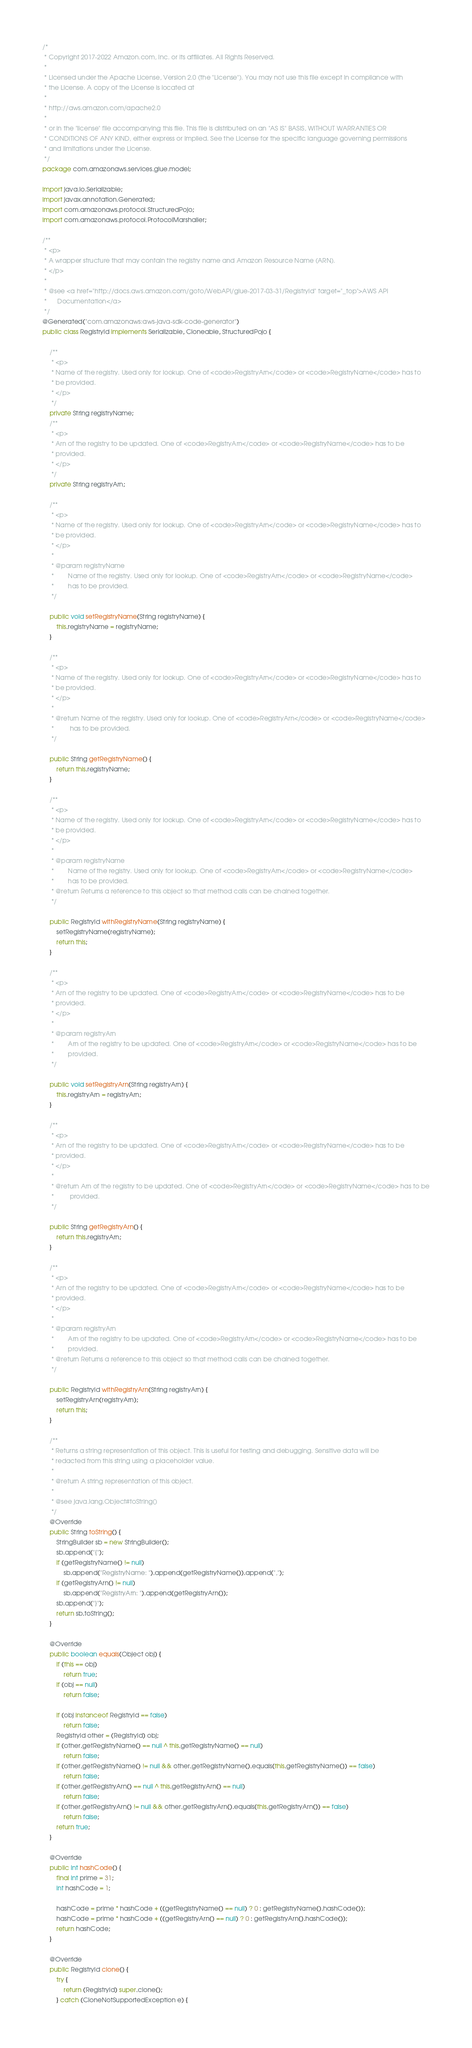<code> <loc_0><loc_0><loc_500><loc_500><_Java_>/*
 * Copyright 2017-2022 Amazon.com, Inc. or its affiliates. All Rights Reserved.
 * 
 * Licensed under the Apache License, Version 2.0 (the "License"). You may not use this file except in compliance with
 * the License. A copy of the License is located at
 * 
 * http://aws.amazon.com/apache2.0
 * 
 * or in the "license" file accompanying this file. This file is distributed on an "AS IS" BASIS, WITHOUT WARRANTIES OR
 * CONDITIONS OF ANY KIND, either express or implied. See the License for the specific language governing permissions
 * and limitations under the License.
 */
package com.amazonaws.services.glue.model;

import java.io.Serializable;
import javax.annotation.Generated;
import com.amazonaws.protocol.StructuredPojo;
import com.amazonaws.protocol.ProtocolMarshaller;

/**
 * <p>
 * A wrapper structure that may contain the registry name and Amazon Resource Name (ARN).
 * </p>
 * 
 * @see <a href="http://docs.aws.amazon.com/goto/WebAPI/glue-2017-03-31/RegistryId" target="_top">AWS API
 *      Documentation</a>
 */
@Generated("com.amazonaws:aws-java-sdk-code-generator")
public class RegistryId implements Serializable, Cloneable, StructuredPojo {

    /**
     * <p>
     * Name of the registry. Used only for lookup. One of <code>RegistryArn</code> or <code>RegistryName</code> has to
     * be provided.
     * </p>
     */
    private String registryName;
    /**
     * <p>
     * Arn of the registry to be updated. One of <code>RegistryArn</code> or <code>RegistryName</code> has to be
     * provided.
     * </p>
     */
    private String registryArn;

    /**
     * <p>
     * Name of the registry. Used only for lookup. One of <code>RegistryArn</code> or <code>RegistryName</code> has to
     * be provided.
     * </p>
     * 
     * @param registryName
     *        Name of the registry. Used only for lookup. One of <code>RegistryArn</code> or <code>RegistryName</code>
     *        has to be provided.
     */

    public void setRegistryName(String registryName) {
        this.registryName = registryName;
    }

    /**
     * <p>
     * Name of the registry. Used only for lookup. One of <code>RegistryArn</code> or <code>RegistryName</code> has to
     * be provided.
     * </p>
     * 
     * @return Name of the registry. Used only for lookup. One of <code>RegistryArn</code> or <code>RegistryName</code>
     *         has to be provided.
     */

    public String getRegistryName() {
        return this.registryName;
    }

    /**
     * <p>
     * Name of the registry. Used only for lookup. One of <code>RegistryArn</code> or <code>RegistryName</code> has to
     * be provided.
     * </p>
     * 
     * @param registryName
     *        Name of the registry. Used only for lookup. One of <code>RegistryArn</code> or <code>RegistryName</code>
     *        has to be provided.
     * @return Returns a reference to this object so that method calls can be chained together.
     */

    public RegistryId withRegistryName(String registryName) {
        setRegistryName(registryName);
        return this;
    }

    /**
     * <p>
     * Arn of the registry to be updated. One of <code>RegistryArn</code> or <code>RegistryName</code> has to be
     * provided.
     * </p>
     * 
     * @param registryArn
     *        Arn of the registry to be updated. One of <code>RegistryArn</code> or <code>RegistryName</code> has to be
     *        provided.
     */

    public void setRegistryArn(String registryArn) {
        this.registryArn = registryArn;
    }

    /**
     * <p>
     * Arn of the registry to be updated. One of <code>RegistryArn</code> or <code>RegistryName</code> has to be
     * provided.
     * </p>
     * 
     * @return Arn of the registry to be updated. One of <code>RegistryArn</code> or <code>RegistryName</code> has to be
     *         provided.
     */

    public String getRegistryArn() {
        return this.registryArn;
    }

    /**
     * <p>
     * Arn of the registry to be updated. One of <code>RegistryArn</code> or <code>RegistryName</code> has to be
     * provided.
     * </p>
     * 
     * @param registryArn
     *        Arn of the registry to be updated. One of <code>RegistryArn</code> or <code>RegistryName</code> has to be
     *        provided.
     * @return Returns a reference to this object so that method calls can be chained together.
     */

    public RegistryId withRegistryArn(String registryArn) {
        setRegistryArn(registryArn);
        return this;
    }

    /**
     * Returns a string representation of this object. This is useful for testing and debugging. Sensitive data will be
     * redacted from this string using a placeholder value.
     *
     * @return A string representation of this object.
     *
     * @see java.lang.Object#toString()
     */
    @Override
    public String toString() {
        StringBuilder sb = new StringBuilder();
        sb.append("{");
        if (getRegistryName() != null)
            sb.append("RegistryName: ").append(getRegistryName()).append(",");
        if (getRegistryArn() != null)
            sb.append("RegistryArn: ").append(getRegistryArn());
        sb.append("}");
        return sb.toString();
    }

    @Override
    public boolean equals(Object obj) {
        if (this == obj)
            return true;
        if (obj == null)
            return false;

        if (obj instanceof RegistryId == false)
            return false;
        RegistryId other = (RegistryId) obj;
        if (other.getRegistryName() == null ^ this.getRegistryName() == null)
            return false;
        if (other.getRegistryName() != null && other.getRegistryName().equals(this.getRegistryName()) == false)
            return false;
        if (other.getRegistryArn() == null ^ this.getRegistryArn() == null)
            return false;
        if (other.getRegistryArn() != null && other.getRegistryArn().equals(this.getRegistryArn()) == false)
            return false;
        return true;
    }

    @Override
    public int hashCode() {
        final int prime = 31;
        int hashCode = 1;

        hashCode = prime * hashCode + ((getRegistryName() == null) ? 0 : getRegistryName().hashCode());
        hashCode = prime * hashCode + ((getRegistryArn() == null) ? 0 : getRegistryArn().hashCode());
        return hashCode;
    }

    @Override
    public RegistryId clone() {
        try {
            return (RegistryId) super.clone();
        } catch (CloneNotSupportedException e) {</code> 